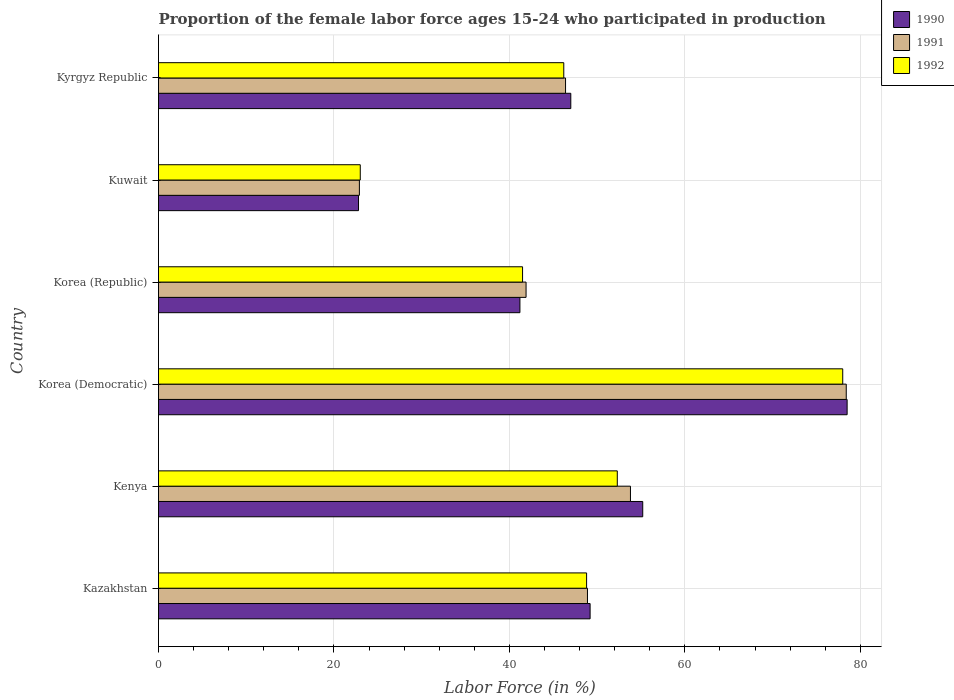What is the label of the 4th group of bars from the top?
Give a very brief answer. Korea (Democratic). What is the proportion of the female labor force who participated in production in 1991 in Korea (Republic)?
Your answer should be compact. 41.9. Across all countries, what is the minimum proportion of the female labor force who participated in production in 1990?
Provide a succinct answer. 22.8. In which country was the proportion of the female labor force who participated in production in 1992 maximum?
Keep it short and to the point. Korea (Democratic). In which country was the proportion of the female labor force who participated in production in 1992 minimum?
Your answer should be compact. Kuwait. What is the total proportion of the female labor force who participated in production in 1992 in the graph?
Make the answer very short. 289.8. What is the difference between the proportion of the female labor force who participated in production in 1992 in Kazakhstan and that in Kyrgyz Republic?
Ensure brevity in your answer.  2.6. What is the difference between the proportion of the female labor force who participated in production in 1991 in Kenya and the proportion of the female labor force who participated in production in 1992 in Korea (Republic)?
Offer a terse response. 12.3. What is the average proportion of the female labor force who participated in production in 1991 per country?
Provide a succinct answer. 48.72. What is the difference between the proportion of the female labor force who participated in production in 1991 and proportion of the female labor force who participated in production in 1992 in Kyrgyz Republic?
Make the answer very short. 0.2. In how many countries, is the proportion of the female labor force who participated in production in 1991 greater than 24 %?
Make the answer very short. 5. What is the ratio of the proportion of the female labor force who participated in production in 1991 in Kazakhstan to that in Korea (Republic)?
Provide a succinct answer. 1.17. What is the difference between the highest and the second highest proportion of the female labor force who participated in production in 1992?
Keep it short and to the point. 25.7. In how many countries, is the proportion of the female labor force who participated in production in 1992 greater than the average proportion of the female labor force who participated in production in 1992 taken over all countries?
Keep it short and to the point. 3. What does the 2nd bar from the bottom in Kenya represents?
Provide a short and direct response. 1991. What is the difference between two consecutive major ticks on the X-axis?
Provide a succinct answer. 20. Does the graph contain grids?
Provide a succinct answer. Yes. What is the title of the graph?
Give a very brief answer. Proportion of the female labor force ages 15-24 who participated in production. Does "2009" appear as one of the legend labels in the graph?
Provide a succinct answer. No. What is the label or title of the Y-axis?
Ensure brevity in your answer.  Country. What is the Labor Force (in %) in 1990 in Kazakhstan?
Provide a succinct answer. 49.2. What is the Labor Force (in %) of 1991 in Kazakhstan?
Your answer should be compact. 48.9. What is the Labor Force (in %) in 1992 in Kazakhstan?
Provide a short and direct response. 48.8. What is the Labor Force (in %) of 1990 in Kenya?
Offer a very short reply. 55.2. What is the Labor Force (in %) of 1991 in Kenya?
Offer a terse response. 53.8. What is the Labor Force (in %) in 1992 in Kenya?
Make the answer very short. 52.3. What is the Labor Force (in %) of 1990 in Korea (Democratic)?
Provide a short and direct response. 78.5. What is the Labor Force (in %) of 1991 in Korea (Democratic)?
Provide a succinct answer. 78.4. What is the Labor Force (in %) in 1992 in Korea (Democratic)?
Provide a succinct answer. 78. What is the Labor Force (in %) of 1990 in Korea (Republic)?
Provide a short and direct response. 41.2. What is the Labor Force (in %) of 1991 in Korea (Republic)?
Offer a terse response. 41.9. What is the Labor Force (in %) of 1992 in Korea (Republic)?
Keep it short and to the point. 41.5. What is the Labor Force (in %) of 1990 in Kuwait?
Ensure brevity in your answer.  22.8. What is the Labor Force (in %) of 1991 in Kuwait?
Give a very brief answer. 22.9. What is the Labor Force (in %) in 1992 in Kuwait?
Make the answer very short. 23. What is the Labor Force (in %) in 1990 in Kyrgyz Republic?
Your answer should be compact. 47. What is the Labor Force (in %) of 1991 in Kyrgyz Republic?
Your response must be concise. 46.4. What is the Labor Force (in %) of 1992 in Kyrgyz Republic?
Your response must be concise. 46.2. Across all countries, what is the maximum Labor Force (in %) of 1990?
Make the answer very short. 78.5. Across all countries, what is the maximum Labor Force (in %) in 1991?
Provide a short and direct response. 78.4. Across all countries, what is the minimum Labor Force (in %) of 1990?
Your answer should be compact. 22.8. Across all countries, what is the minimum Labor Force (in %) in 1991?
Offer a very short reply. 22.9. What is the total Labor Force (in %) of 1990 in the graph?
Ensure brevity in your answer.  293.9. What is the total Labor Force (in %) of 1991 in the graph?
Your response must be concise. 292.3. What is the total Labor Force (in %) in 1992 in the graph?
Your answer should be very brief. 289.8. What is the difference between the Labor Force (in %) in 1990 in Kazakhstan and that in Kenya?
Provide a short and direct response. -6. What is the difference between the Labor Force (in %) in 1991 in Kazakhstan and that in Kenya?
Make the answer very short. -4.9. What is the difference between the Labor Force (in %) in 1992 in Kazakhstan and that in Kenya?
Offer a very short reply. -3.5. What is the difference between the Labor Force (in %) in 1990 in Kazakhstan and that in Korea (Democratic)?
Your answer should be very brief. -29.3. What is the difference between the Labor Force (in %) in 1991 in Kazakhstan and that in Korea (Democratic)?
Your answer should be compact. -29.5. What is the difference between the Labor Force (in %) in 1992 in Kazakhstan and that in Korea (Democratic)?
Your answer should be very brief. -29.2. What is the difference between the Labor Force (in %) of 1990 in Kazakhstan and that in Korea (Republic)?
Provide a succinct answer. 8. What is the difference between the Labor Force (in %) of 1992 in Kazakhstan and that in Korea (Republic)?
Give a very brief answer. 7.3. What is the difference between the Labor Force (in %) of 1990 in Kazakhstan and that in Kuwait?
Your answer should be compact. 26.4. What is the difference between the Labor Force (in %) of 1992 in Kazakhstan and that in Kuwait?
Provide a succinct answer. 25.8. What is the difference between the Labor Force (in %) in 1991 in Kazakhstan and that in Kyrgyz Republic?
Offer a very short reply. 2.5. What is the difference between the Labor Force (in %) in 1992 in Kazakhstan and that in Kyrgyz Republic?
Offer a terse response. 2.6. What is the difference between the Labor Force (in %) in 1990 in Kenya and that in Korea (Democratic)?
Give a very brief answer. -23.3. What is the difference between the Labor Force (in %) of 1991 in Kenya and that in Korea (Democratic)?
Give a very brief answer. -24.6. What is the difference between the Labor Force (in %) of 1992 in Kenya and that in Korea (Democratic)?
Offer a terse response. -25.7. What is the difference between the Labor Force (in %) in 1990 in Kenya and that in Korea (Republic)?
Your answer should be very brief. 14. What is the difference between the Labor Force (in %) in 1990 in Kenya and that in Kuwait?
Your answer should be compact. 32.4. What is the difference between the Labor Force (in %) in 1991 in Kenya and that in Kuwait?
Provide a short and direct response. 30.9. What is the difference between the Labor Force (in %) of 1992 in Kenya and that in Kuwait?
Your answer should be compact. 29.3. What is the difference between the Labor Force (in %) of 1991 in Kenya and that in Kyrgyz Republic?
Keep it short and to the point. 7.4. What is the difference between the Labor Force (in %) in 1992 in Kenya and that in Kyrgyz Republic?
Offer a very short reply. 6.1. What is the difference between the Labor Force (in %) in 1990 in Korea (Democratic) and that in Korea (Republic)?
Keep it short and to the point. 37.3. What is the difference between the Labor Force (in %) of 1991 in Korea (Democratic) and that in Korea (Republic)?
Ensure brevity in your answer.  36.5. What is the difference between the Labor Force (in %) in 1992 in Korea (Democratic) and that in Korea (Republic)?
Offer a terse response. 36.5. What is the difference between the Labor Force (in %) in 1990 in Korea (Democratic) and that in Kuwait?
Your answer should be very brief. 55.7. What is the difference between the Labor Force (in %) of 1991 in Korea (Democratic) and that in Kuwait?
Ensure brevity in your answer.  55.5. What is the difference between the Labor Force (in %) in 1990 in Korea (Democratic) and that in Kyrgyz Republic?
Your answer should be compact. 31.5. What is the difference between the Labor Force (in %) of 1992 in Korea (Democratic) and that in Kyrgyz Republic?
Offer a very short reply. 31.8. What is the difference between the Labor Force (in %) in 1990 in Korea (Republic) and that in Kuwait?
Your answer should be compact. 18.4. What is the difference between the Labor Force (in %) of 1991 in Korea (Republic) and that in Kuwait?
Offer a terse response. 19. What is the difference between the Labor Force (in %) in 1990 in Korea (Republic) and that in Kyrgyz Republic?
Provide a short and direct response. -5.8. What is the difference between the Labor Force (in %) in 1990 in Kuwait and that in Kyrgyz Republic?
Ensure brevity in your answer.  -24.2. What is the difference between the Labor Force (in %) in 1991 in Kuwait and that in Kyrgyz Republic?
Offer a very short reply. -23.5. What is the difference between the Labor Force (in %) in 1992 in Kuwait and that in Kyrgyz Republic?
Ensure brevity in your answer.  -23.2. What is the difference between the Labor Force (in %) in 1990 in Kazakhstan and the Labor Force (in %) in 1991 in Korea (Democratic)?
Make the answer very short. -29.2. What is the difference between the Labor Force (in %) of 1990 in Kazakhstan and the Labor Force (in %) of 1992 in Korea (Democratic)?
Your answer should be very brief. -28.8. What is the difference between the Labor Force (in %) in 1991 in Kazakhstan and the Labor Force (in %) in 1992 in Korea (Democratic)?
Your answer should be very brief. -29.1. What is the difference between the Labor Force (in %) in 1990 in Kazakhstan and the Labor Force (in %) in 1991 in Korea (Republic)?
Provide a succinct answer. 7.3. What is the difference between the Labor Force (in %) of 1990 in Kazakhstan and the Labor Force (in %) of 1992 in Korea (Republic)?
Offer a very short reply. 7.7. What is the difference between the Labor Force (in %) of 1991 in Kazakhstan and the Labor Force (in %) of 1992 in Korea (Republic)?
Provide a short and direct response. 7.4. What is the difference between the Labor Force (in %) in 1990 in Kazakhstan and the Labor Force (in %) in 1991 in Kuwait?
Provide a succinct answer. 26.3. What is the difference between the Labor Force (in %) of 1990 in Kazakhstan and the Labor Force (in %) of 1992 in Kuwait?
Your response must be concise. 26.2. What is the difference between the Labor Force (in %) of 1991 in Kazakhstan and the Labor Force (in %) of 1992 in Kuwait?
Offer a terse response. 25.9. What is the difference between the Labor Force (in %) in 1990 in Kazakhstan and the Labor Force (in %) in 1992 in Kyrgyz Republic?
Provide a succinct answer. 3. What is the difference between the Labor Force (in %) in 1990 in Kenya and the Labor Force (in %) in 1991 in Korea (Democratic)?
Offer a very short reply. -23.2. What is the difference between the Labor Force (in %) in 1990 in Kenya and the Labor Force (in %) in 1992 in Korea (Democratic)?
Offer a terse response. -22.8. What is the difference between the Labor Force (in %) in 1991 in Kenya and the Labor Force (in %) in 1992 in Korea (Democratic)?
Your response must be concise. -24.2. What is the difference between the Labor Force (in %) of 1990 in Kenya and the Labor Force (in %) of 1992 in Korea (Republic)?
Your answer should be compact. 13.7. What is the difference between the Labor Force (in %) of 1991 in Kenya and the Labor Force (in %) of 1992 in Korea (Republic)?
Give a very brief answer. 12.3. What is the difference between the Labor Force (in %) of 1990 in Kenya and the Labor Force (in %) of 1991 in Kuwait?
Provide a succinct answer. 32.3. What is the difference between the Labor Force (in %) of 1990 in Kenya and the Labor Force (in %) of 1992 in Kuwait?
Offer a very short reply. 32.2. What is the difference between the Labor Force (in %) of 1991 in Kenya and the Labor Force (in %) of 1992 in Kuwait?
Your response must be concise. 30.8. What is the difference between the Labor Force (in %) in 1990 in Kenya and the Labor Force (in %) in 1991 in Kyrgyz Republic?
Offer a terse response. 8.8. What is the difference between the Labor Force (in %) in 1990 in Kenya and the Labor Force (in %) in 1992 in Kyrgyz Republic?
Give a very brief answer. 9. What is the difference between the Labor Force (in %) in 1991 in Kenya and the Labor Force (in %) in 1992 in Kyrgyz Republic?
Give a very brief answer. 7.6. What is the difference between the Labor Force (in %) of 1990 in Korea (Democratic) and the Labor Force (in %) of 1991 in Korea (Republic)?
Ensure brevity in your answer.  36.6. What is the difference between the Labor Force (in %) of 1991 in Korea (Democratic) and the Labor Force (in %) of 1992 in Korea (Republic)?
Offer a terse response. 36.9. What is the difference between the Labor Force (in %) of 1990 in Korea (Democratic) and the Labor Force (in %) of 1991 in Kuwait?
Your response must be concise. 55.6. What is the difference between the Labor Force (in %) in 1990 in Korea (Democratic) and the Labor Force (in %) in 1992 in Kuwait?
Keep it short and to the point. 55.5. What is the difference between the Labor Force (in %) of 1991 in Korea (Democratic) and the Labor Force (in %) of 1992 in Kuwait?
Your response must be concise. 55.4. What is the difference between the Labor Force (in %) in 1990 in Korea (Democratic) and the Labor Force (in %) in 1991 in Kyrgyz Republic?
Keep it short and to the point. 32.1. What is the difference between the Labor Force (in %) of 1990 in Korea (Democratic) and the Labor Force (in %) of 1992 in Kyrgyz Republic?
Your response must be concise. 32.3. What is the difference between the Labor Force (in %) in 1991 in Korea (Democratic) and the Labor Force (in %) in 1992 in Kyrgyz Republic?
Provide a succinct answer. 32.2. What is the difference between the Labor Force (in %) in 1990 in Korea (Republic) and the Labor Force (in %) in 1992 in Kyrgyz Republic?
Your answer should be compact. -5. What is the difference between the Labor Force (in %) in 1990 in Kuwait and the Labor Force (in %) in 1991 in Kyrgyz Republic?
Provide a succinct answer. -23.6. What is the difference between the Labor Force (in %) in 1990 in Kuwait and the Labor Force (in %) in 1992 in Kyrgyz Republic?
Offer a terse response. -23.4. What is the difference between the Labor Force (in %) of 1991 in Kuwait and the Labor Force (in %) of 1992 in Kyrgyz Republic?
Offer a very short reply. -23.3. What is the average Labor Force (in %) in 1990 per country?
Provide a succinct answer. 48.98. What is the average Labor Force (in %) of 1991 per country?
Offer a very short reply. 48.72. What is the average Labor Force (in %) of 1992 per country?
Ensure brevity in your answer.  48.3. What is the difference between the Labor Force (in %) in 1990 and Labor Force (in %) in 1991 in Kazakhstan?
Ensure brevity in your answer.  0.3. What is the difference between the Labor Force (in %) in 1990 and Labor Force (in %) in 1992 in Kazakhstan?
Your answer should be compact. 0.4. What is the difference between the Labor Force (in %) in 1990 and Labor Force (in %) in 1991 in Kenya?
Give a very brief answer. 1.4. What is the difference between the Labor Force (in %) of 1990 and Labor Force (in %) of 1992 in Kenya?
Offer a terse response. 2.9. What is the difference between the Labor Force (in %) in 1990 and Labor Force (in %) in 1991 in Korea (Democratic)?
Give a very brief answer. 0.1. What is the difference between the Labor Force (in %) in 1990 and Labor Force (in %) in 1992 in Korea (Democratic)?
Give a very brief answer. 0.5. What is the difference between the Labor Force (in %) of 1990 and Labor Force (in %) of 1991 in Korea (Republic)?
Keep it short and to the point. -0.7. What is the difference between the Labor Force (in %) of 1991 and Labor Force (in %) of 1992 in Korea (Republic)?
Offer a terse response. 0.4. What is the difference between the Labor Force (in %) of 1991 and Labor Force (in %) of 1992 in Kuwait?
Provide a succinct answer. -0.1. What is the difference between the Labor Force (in %) of 1990 and Labor Force (in %) of 1991 in Kyrgyz Republic?
Ensure brevity in your answer.  0.6. What is the ratio of the Labor Force (in %) of 1990 in Kazakhstan to that in Kenya?
Ensure brevity in your answer.  0.89. What is the ratio of the Labor Force (in %) in 1991 in Kazakhstan to that in Kenya?
Offer a terse response. 0.91. What is the ratio of the Labor Force (in %) of 1992 in Kazakhstan to that in Kenya?
Your answer should be very brief. 0.93. What is the ratio of the Labor Force (in %) in 1990 in Kazakhstan to that in Korea (Democratic)?
Ensure brevity in your answer.  0.63. What is the ratio of the Labor Force (in %) in 1991 in Kazakhstan to that in Korea (Democratic)?
Ensure brevity in your answer.  0.62. What is the ratio of the Labor Force (in %) in 1992 in Kazakhstan to that in Korea (Democratic)?
Ensure brevity in your answer.  0.63. What is the ratio of the Labor Force (in %) in 1990 in Kazakhstan to that in Korea (Republic)?
Provide a short and direct response. 1.19. What is the ratio of the Labor Force (in %) in 1991 in Kazakhstan to that in Korea (Republic)?
Make the answer very short. 1.17. What is the ratio of the Labor Force (in %) in 1992 in Kazakhstan to that in Korea (Republic)?
Keep it short and to the point. 1.18. What is the ratio of the Labor Force (in %) in 1990 in Kazakhstan to that in Kuwait?
Ensure brevity in your answer.  2.16. What is the ratio of the Labor Force (in %) of 1991 in Kazakhstan to that in Kuwait?
Ensure brevity in your answer.  2.14. What is the ratio of the Labor Force (in %) of 1992 in Kazakhstan to that in Kuwait?
Offer a terse response. 2.12. What is the ratio of the Labor Force (in %) of 1990 in Kazakhstan to that in Kyrgyz Republic?
Keep it short and to the point. 1.05. What is the ratio of the Labor Force (in %) in 1991 in Kazakhstan to that in Kyrgyz Republic?
Offer a very short reply. 1.05. What is the ratio of the Labor Force (in %) in 1992 in Kazakhstan to that in Kyrgyz Republic?
Keep it short and to the point. 1.06. What is the ratio of the Labor Force (in %) in 1990 in Kenya to that in Korea (Democratic)?
Give a very brief answer. 0.7. What is the ratio of the Labor Force (in %) in 1991 in Kenya to that in Korea (Democratic)?
Your answer should be compact. 0.69. What is the ratio of the Labor Force (in %) of 1992 in Kenya to that in Korea (Democratic)?
Your response must be concise. 0.67. What is the ratio of the Labor Force (in %) of 1990 in Kenya to that in Korea (Republic)?
Your answer should be compact. 1.34. What is the ratio of the Labor Force (in %) in 1991 in Kenya to that in Korea (Republic)?
Make the answer very short. 1.28. What is the ratio of the Labor Force (in %) in 1992 in Kenya to that in Korea (Republic)?
Offer a very short reply. 1.26. What is the ratio of the Labor Force (in %) of 1990 in Kenya to that in Kuwait?
Provide a succinct answer. 2.42. What is the ratio of the Labor Force (in %) of 1991 in Kenya to that in Kuwait?
Your answer should be compact. 2.35. What is the ratio of the Labor Force (in %) of 1992 in Kenya to that in Kuwait?
Offer a very short reply. 2.27. What is the ratio of the Labor Force (in %) of 1990 in Kenya to that in Kyrgyz Republic?
Provide a short and direct response. 1.17. What is the ratio of the Labor Force (in %) in 1991 in Kenya to that in Kyrgyz Republic?
Your answer should be compact. 1.16. What is the ratio of the Labor Force (in %) of 1992 in Kenya to that in Kyrgyz Republic?
Provide a succinct answer. 1.13. What is the ratio of the Labor Force (in %) in 1990 in Korea (Democratic) to that in Korea (Republic)?
Make the answer very short. 1.91. What is the ratio of the Labor Force (in %) in 1991 in Korea (Democratic) to that in Korea (Republic)?
Give a very brief answer. 1.87. What is the ratio of the Labor Force (in %) of 1992 in Korea (Democratic) to that in Korea (Republic)?
Provide a short and direct response. 1.88. What is the ratio of the Labor Force (in %) in 1990 in Korea (Democratic) to that in Kuwait?
Your answer should be very brief. 3.44. What is the ratio of the Labor Force (in %) of 1991 in Korea (Democratic) to that in Kuwait?
Keep it short and to the point. 3.42. What is the ratio of the Labor Force (in %) in 1992 in Korea (Democratic) to that in Kuwait?
Ensure brevity in your answer.  3.39. What is the ratio of the Labor Force (in %) of 1990 in Korea (Democratic) to that in Kyrgyz Republic?
Ensure brevity in your answer.  1.67. What is the ratio of the Labor Force (in %) in 1991 in Korea (Democratic) to that in Kyrgyz Republic?
Your response must be concise. 1.69. What is the ratio of the Labor Force (in %) of 1992 in Korea (Democratic) to that in Kyrgyz Republic?
Ensure brevity in your answer.  1.69. What is the ratio of the Labor Force (in %) of 1990 in Korea (Republic) to that in Kuwait?
Your response must be concise. 1.81. What is the ratio of the Labor Force (in %) in 1991 in Korea (Republic) to that in Kuwait?
Provide a short and direct response. 1.83. What is the ratio of the Labor Force (in %) in 1992 in Korea (Republic) to that in Kuwait?
Provide a succinct answer. 1.8. What is the ratio of the Labor Force (in %) of 1990 in Korea (Republic) to that in Kyrgyz Republic?
Give a very brief answer. 0.88. What is the ratio of the Labor Force (in %) in 1991 in Korea (Republic) to that in Kyrgyz Republic?
Give a very brief answer. 0.9. What is the ratio of the Labor Force (in %) of 1992 in Korea (Republic) to that in Kyrgyz Republic?
Keep it short and to the point. 0.9. What is the ratio of the Labor Force (in %) in 1990 in Kuwait to that in Kyrgyz Republic?
Offer a terse response. 0.49. What is the ratio of the Labor Force (in %) in 1991 in Kuwait to that in Kyrgyz Republic?
Ensure brevity in your answer.  0.49. What is the ratio of the Labor Force (in %) in 1992 in Kuwait to that in Kyrgyz Republic?
Offer a terse response. 0.5. What is the difference between the highest and the second highest Labor Force (in %) in 1990?
Give a very brief answer. 23.3. What is the difference between the highest and the second highest Labor Force (in %) in 1991?
Provide a short and direct response. 24.6. What is the difference between the highest and the second highest Labor Force (in %) in 1992?
Offer a terse response. 25.7. What is the difference between the highest and the lowest Labor Force (in %) in 1990?
Offer a very short reply. 55.7. What is the difference between the highest and the lowest Labor Force (in %) of 1991?
Ensure brevity in your answer.  55.5. 